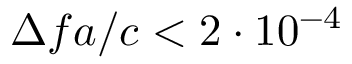Convert formula to latex. <formula><loc_0><loc_0><loc_500><loc_500>\Delta f a / c < 2 \cdot 1 0 ^ { - 4 }</formula> 